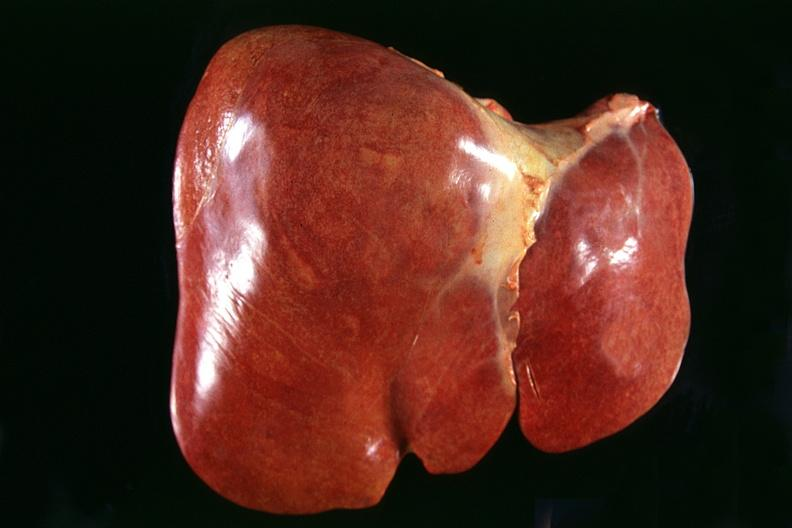does umbilical cord show normal liver?
Answer the question using a single word or phrase. No 